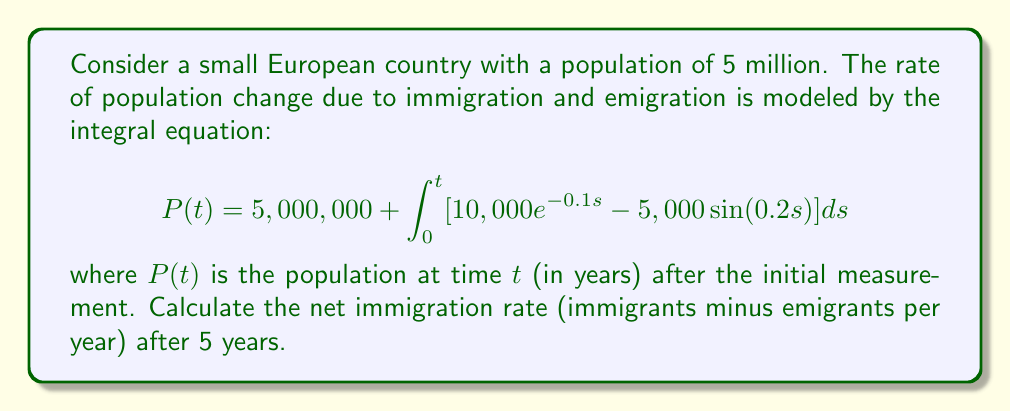Can you answer this question? To solve this problem, we need to follow these steps:

1) The net immigration rate at time $t$ is given by the integrand of the equation:

   $$r(t) = 10,000e^{-0.1t} - 5,000\sin(0.2t)$$

2) We need to evaluate this function at $t = 5$:

   $$r(5) = 10,000e^{-0.1(5)} - 5,000\sin(0.2(5))$$

3) Let's calculate each part separately:

   $10,000e^{-0.1(5)} = 10,000e^{-0.5} \approx 6,065.31$

   $5,000\sin(0.2(5)) = 5,000\sin(1) \approx 4,207.35$

4) Now, we can subtract:

   $r(5) = 6,065.31 - 4,207.35 = 1,857.96$

5) This result represents the net number of people immigrating per year after 5 years.
Answer: 1,858 people per year 